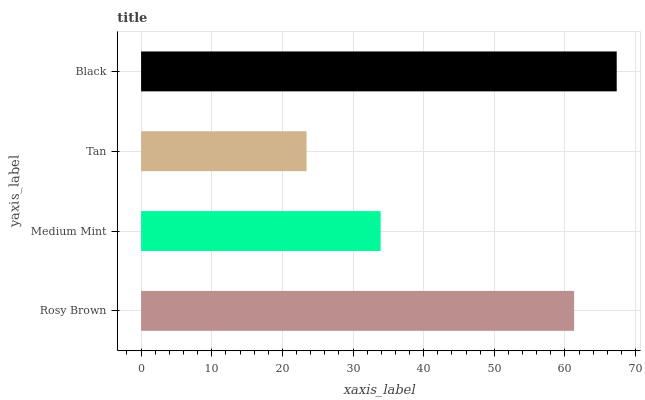Is Tan the minimum?
Answer yes or no. Yes. Is Black the maximum?
Answer yes or no. Yes. Is Medium Mint the minimum?
Answer yes or no. No. Is Medium Mint the maximum?
Answer yes or no. No. Is Rosy Brown greater than Medium Mint?
Answer yes or no. Yes. Is Medium Mint less than Rosy Brown?
Answer yes or no. Yes. Is Medium Mint greater than Rosy Brown?
Answer yes or no. No. Is Rosy Brown less than Medium Mint?
Answer yes or no. No. Is Rosy Brown the high median?
Answer yes or no. Yes. Is Medium Mint the low median?
Answer yes or no. Yes. Is Black the high median?
Answer yes or no. No. Is Tan the low median?
Answer yes or no. No. 